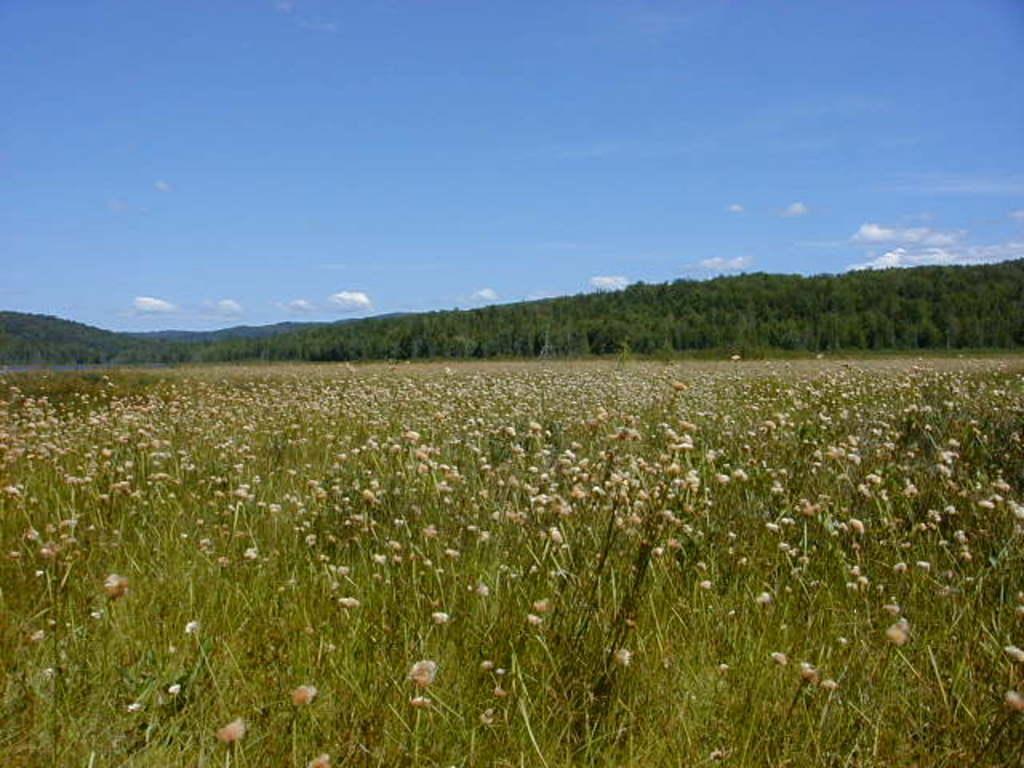Can you describe this image briefly? In the foreground of the image we can see flowers on the plants. In the background, we can see a group of trees, mountains and the cloudy sky. 